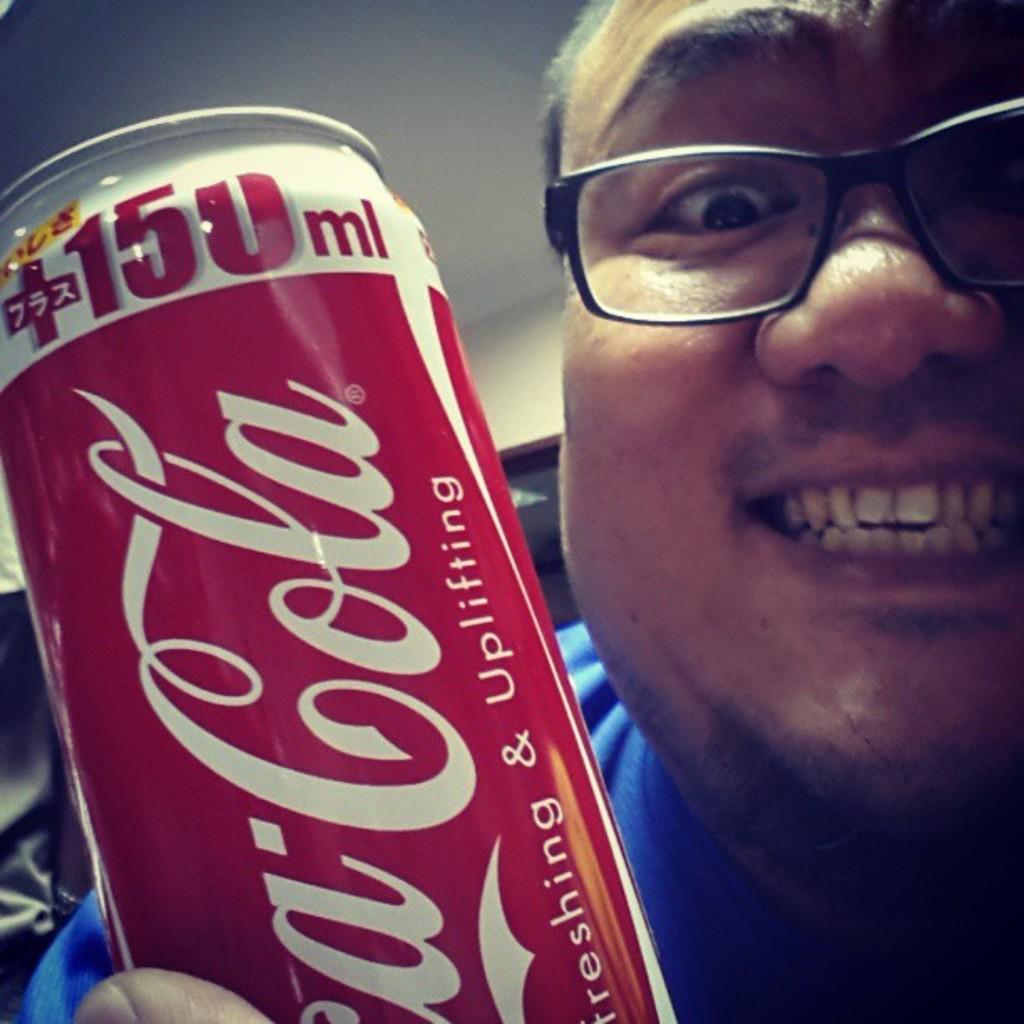What brand soda is shown by this smiling man?
Your answer should be compact. Coca cola. How many ml are in this can?
Your answer should be compact. 150. 